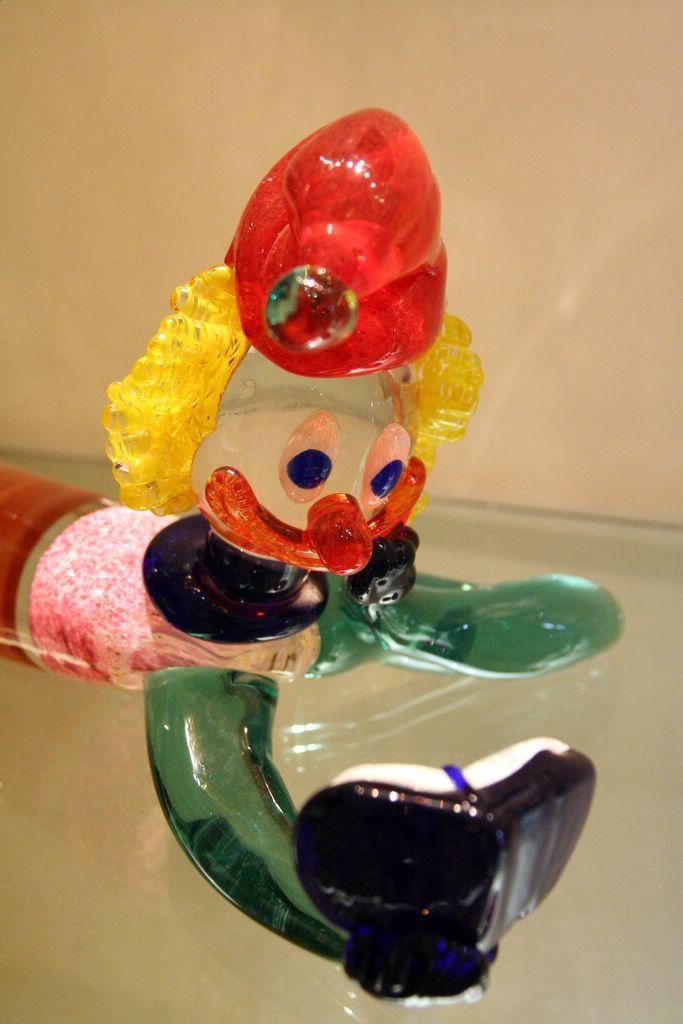Could you give a brief overview of what you see in this image? In this image there is a toy on the glass table. In the background of the image there is a wall. 